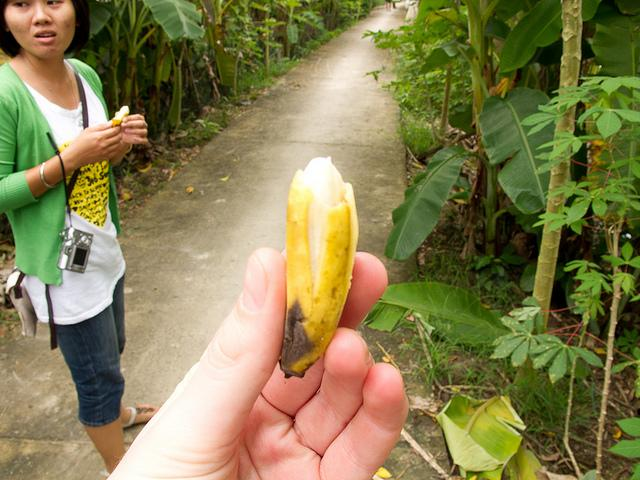The woman eating the fruit is likely on the path for what reason? tourist 